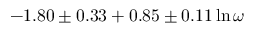<formula> <loc_0><loc_0><loc_500><loc_500>- 1 . 8 0 \pm 0 . 3 3 + 0 . 8 5 \pm 0 . 1 1 \ln \omega</formula> 